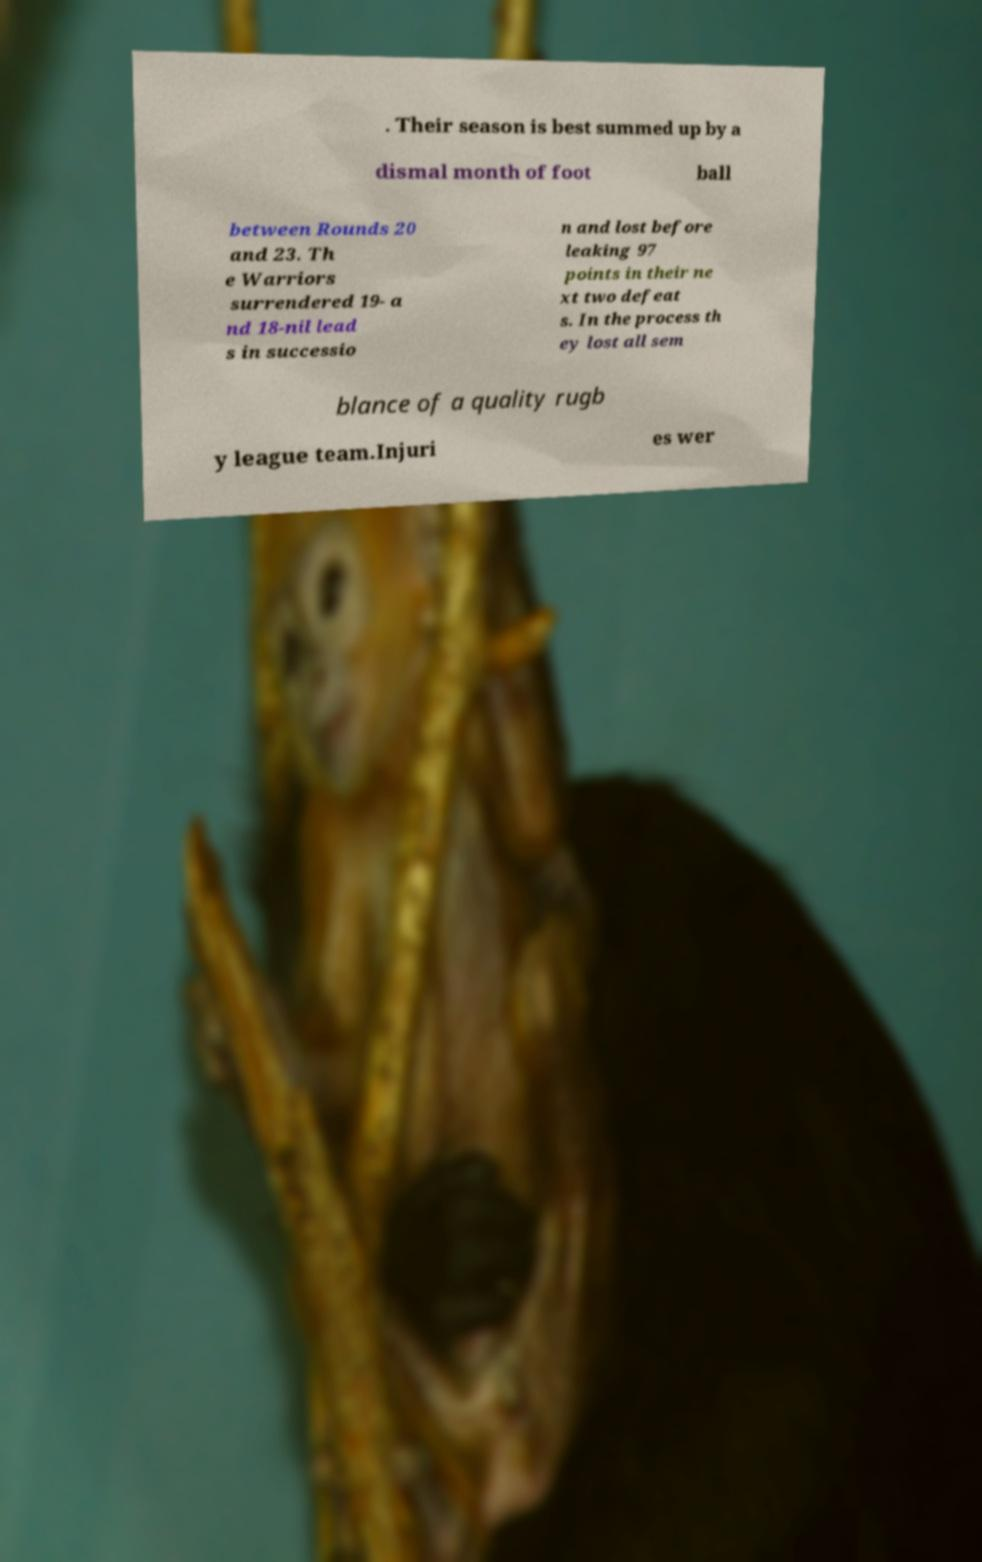Could you extract and type out the text from this image? . Their season is best summed up by a dismal month of foot ball between Rounds 20 and 23. Th e Warriors surrendered 19- a nd 18-nil lead s in successio n and lost before leaking 97 points in their ne xt two defeat s. In the process th ey lost all sem blance of a quality rugb y league team.Injuri es wer 